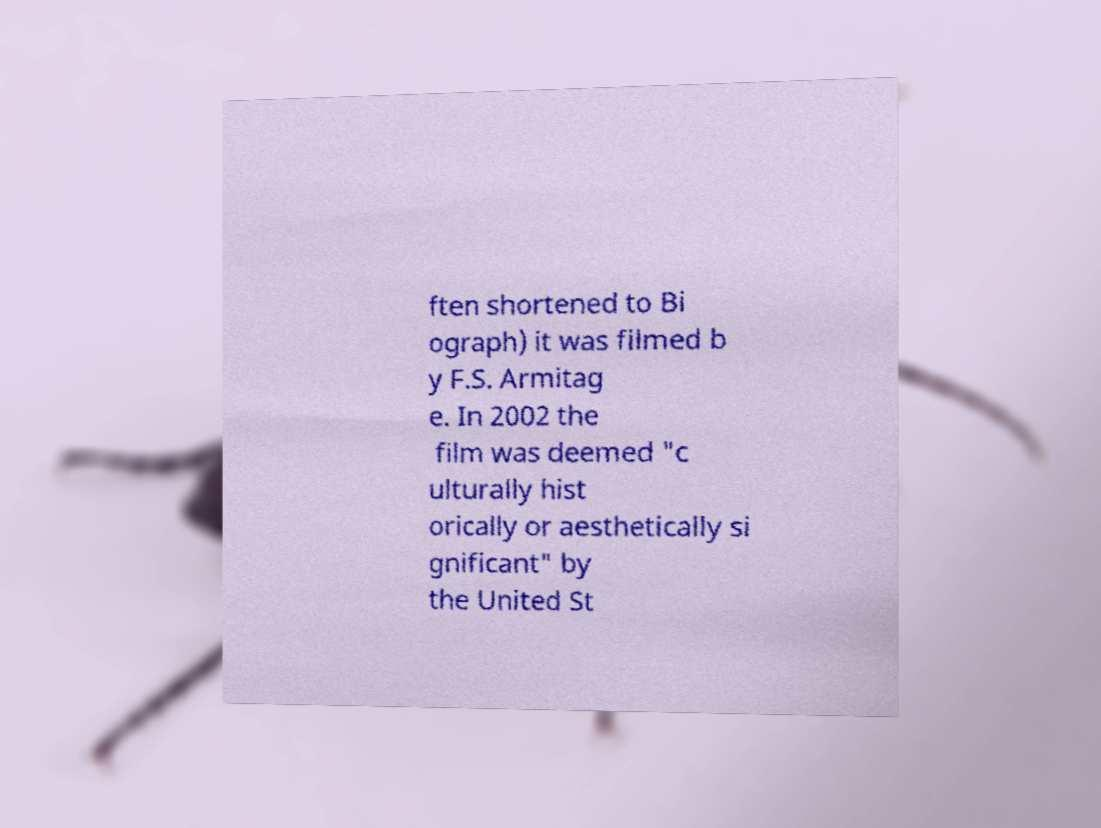For documentation purposes, I need the text within this image transcribed. Could you provide that? ften shortened to Bi ograph) it was filmed b y F.S. Armitag e. In 2002 the film was deemed "c ulturally hist orically or aesthetically si gnificant" by the United St 